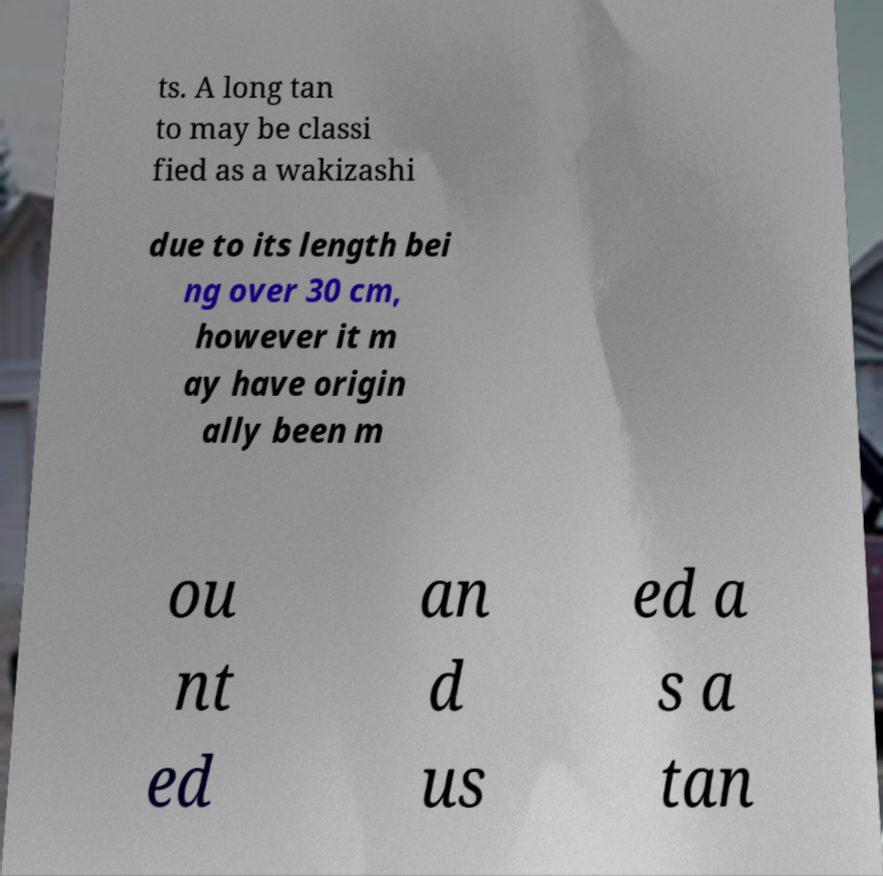Can you accurately transcribe the text from the provided image for me? ts. A long tan to may be classi fied as a wakizashi due to its length bei ng over 30 cm, however it m ay have origin ally been m ou nt ed an d us ed a s a tan 